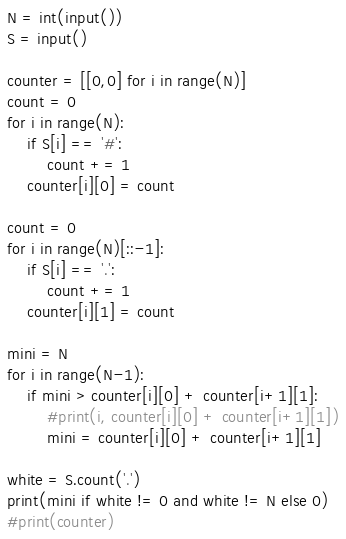<code> <loc_0><loc_0><loc_500><loc_500><_Python_>N = int(input())
S = input()

counter = [[0,0] for i in range(N)]
count = 0
for i in range(N):
    if S[i] == '#':
        count += 1
    counter[i][0] = count

count = 0
for i in range(N)[::-1]:
    if S[i] == '.':
        count += 1
    counter[i][1] = count

mini = N
for i in range(N-1):
    if mini > counter[i][0] + counter[i+1][1]:
        #print(i, counter[i][0] + counter[i+1][1])
        mini = counter[i][0] + counter[i+1][1]

white = S.count('.')
print(mini if white != 0 and white != N else 0)
#print(counter)
</code> 